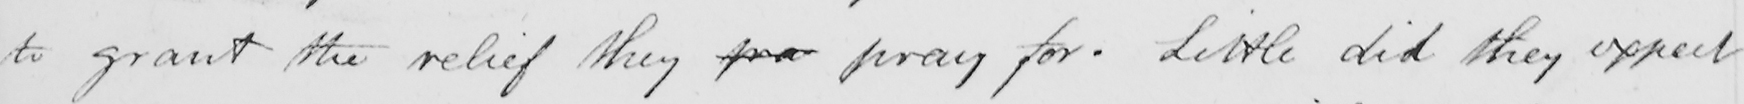What does this handwritten line say? to grant the relief they pra pray for . Little did they expect 